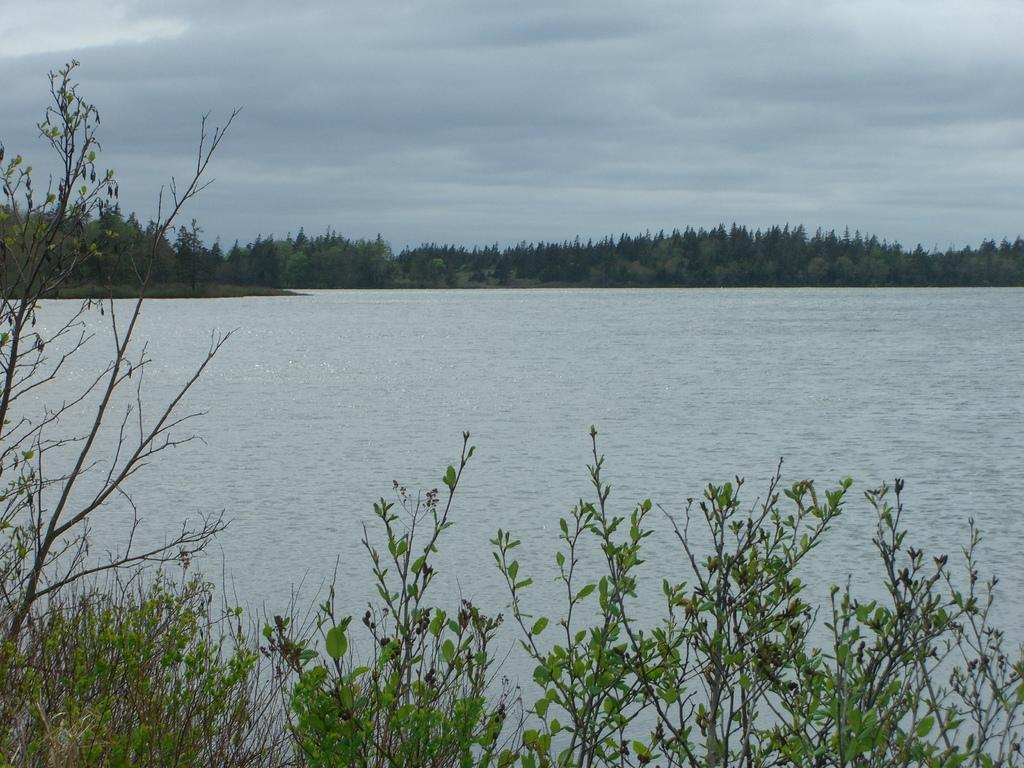What is visible in the image that is not solid? Water is visible in the image. What type of vegetation can be seen in the image? There are trees and plants in the image. What is visible in the background of the image? The sky is visible in the image. What can be seen in the sky in the image? Clouds are present in the sky. What type of fowl can be seen flying over the stream in the image? There is no stream or fowl present in the image. How is the fire being used in the image? There is no fire present in the image. 